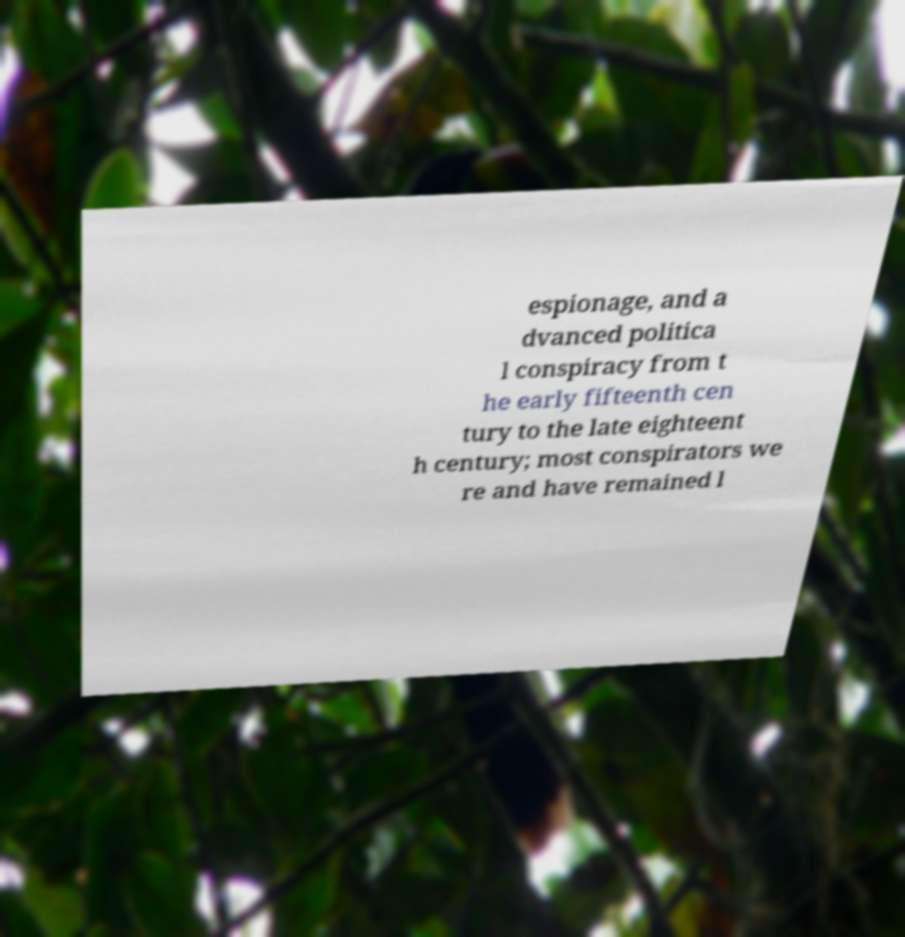Can you accurately transcribe the text from the provided image for me? espionage, and a dvanced politica l conspiracy from t he early fifteenth cen tury to the late eighteent h century; most conspirators we re and have remained l 